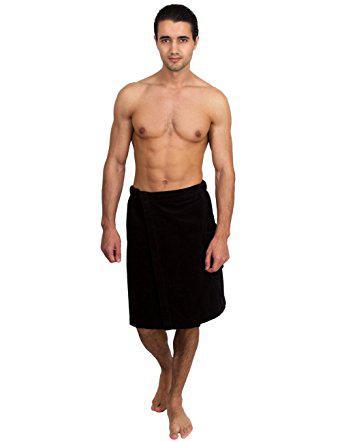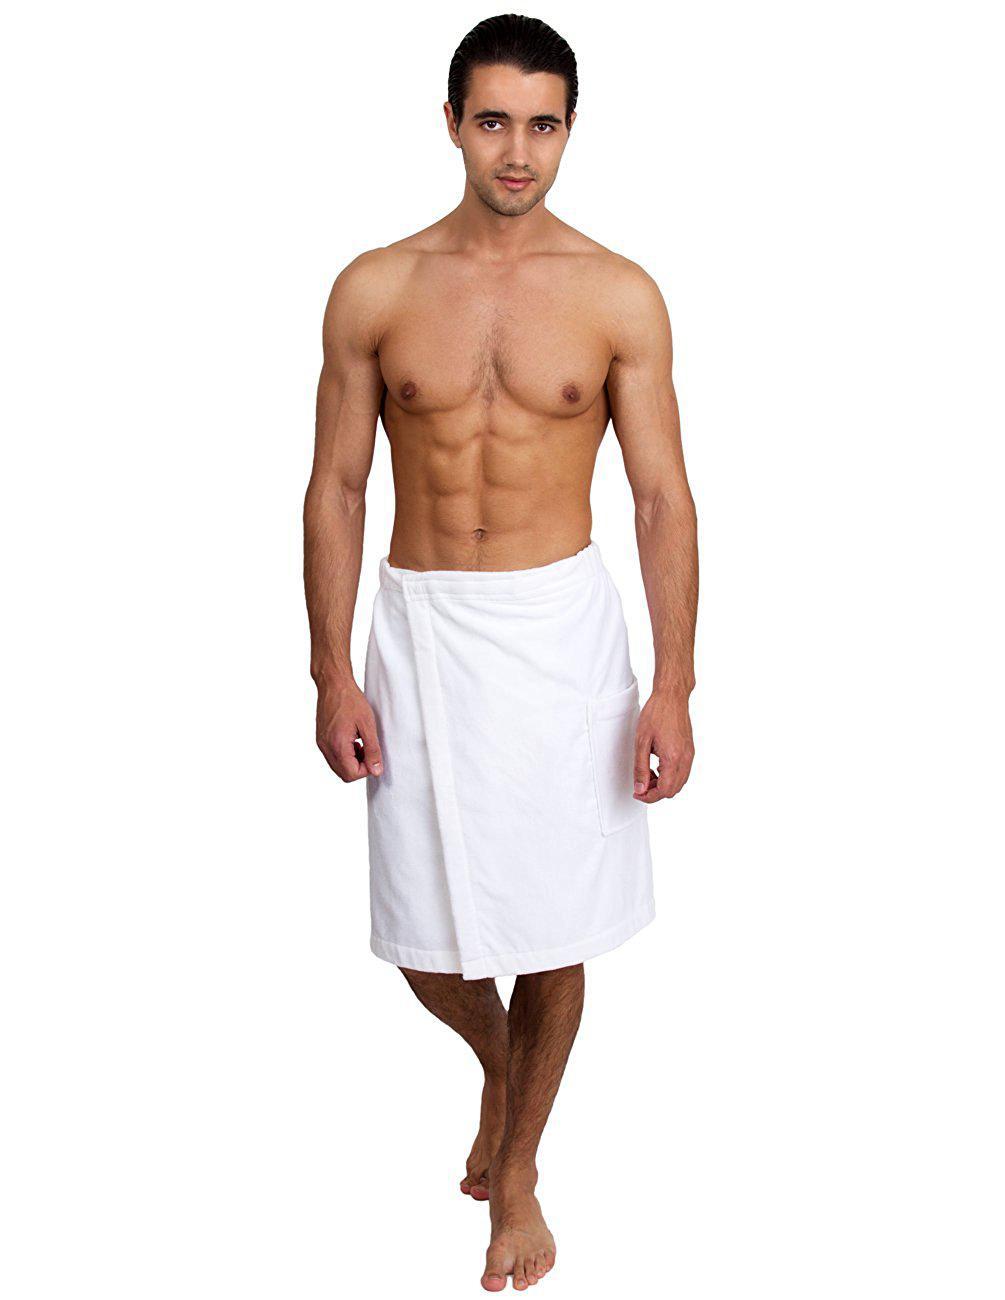The first image is the image on the left, the second image is the image on the right. For the images shown, is this caption "Each image shows one dark-haired man, who faces forward, wearing only a towel wrapped around his waist, and one image features a man wearing a white towel." true? Answer yes or no. Yes. The first image is the image on the left, the second image is the image on the right. Examine the images to the left and right. Is the description "Every photo shows exactly one shirtless man modeling one towel around his waist and the towels are not the same color." accurate? Answer yes or no. Yes. 